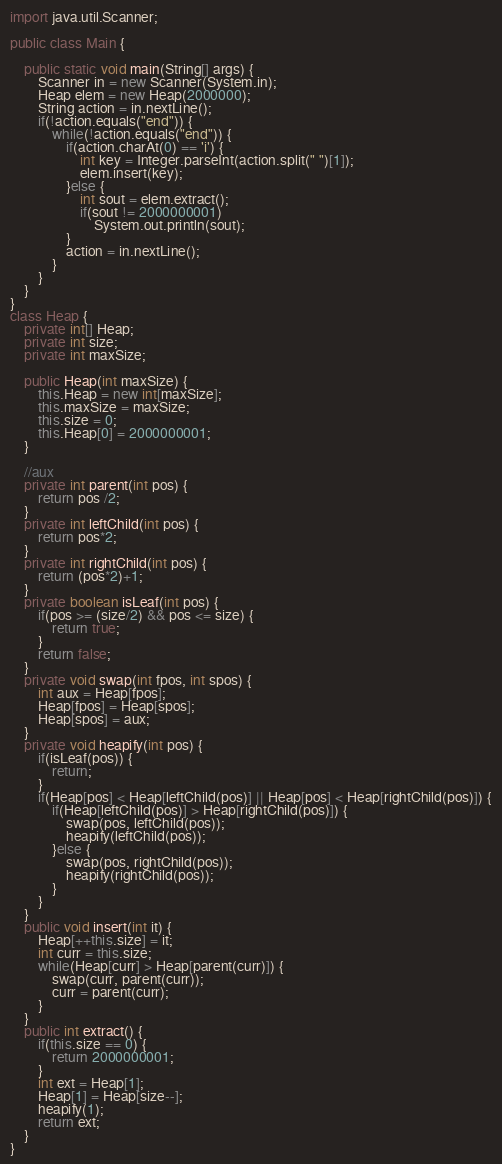Convert code to text. <code><loc_0><loc_0><loc_500><loc_500><_Java_>
import java.util.Scanner;

public class Main {

	public static void main(String[] args) {
		Scanner in = new Scanner(System.in);
		Heap elem = new Heap(2000000);
		String action = in.nextLine();
		if(!action.equals("end")) {
			while(!action.equals("end")) {				
				if(action.charAt(0) == 'i') {
					int key = Integer.parseInt(action.split(" ")[1]);
					elem.insert(key);
				}else {
					int sout = elem.extract();
					if(sout != 2000000001)
						System.out.println(sout);
				}
				action = in.nextLine();
			}
		}
	}
}
class Heap {
	private int[] Heap;
	private int size;
	private int maxSize;
	
	public Heap(int maxSize) {
		this.Heap = new int[maxSize];
		this.maxSize = maxSize;
		this.size = 0;
		this.Heap[0] = 2000000001;
	}
	
	//aux
	private int parent(int pos) {
		return pos /2;
	}
	private int leftChild(int pos) {
		return pos*2;
	}
	private int rightChild(int pos) {
		return (pos*2)+1;
	}
	private boolean isLeaf(int pos) {
		if(pos >= (size/2) && pos <= size) {
			return true; 
		}
		return false;
	}
	private void swap(int fpos, int spos) {
		int aux = Heap[fpos];
		Heap[fpos] = Heap[spos];
		Heap[spos] = aux;
	}
	private void heapify(int pos) {
		if(isLeaf(pos)) {
			return;
		}
		if(Heap[pos] < Heap[leftChild(pos)] || Heap[pos] < Heap[rightChild(pos)]) {
			if(Heap[leftChild(pos)] > Heap[rightChild(pos)]) {
				swap(pos, leftChild(pos));
				heapify(leftChild(pos));
			}else {
				swap(pos, rightChild(pos));
				heapify(rightChild(pos));
			}
		}
	}
	public void insert(int it) {
		Heap[++this.size] = it;
		int curr = this.size;
		while(Heap[curr] > Heap[parent(curr)]) {
			swap(curr, parent(curr));
			curr = parent(curr);
		}
	}
	public int extract() {
		if(this.size == 0) {
			return 2000000001;
		}
		int ext = Heap[1];
		Heap[1] = Heap[size--];
		heapify(1);
		return ext;
	}
}

</code> 